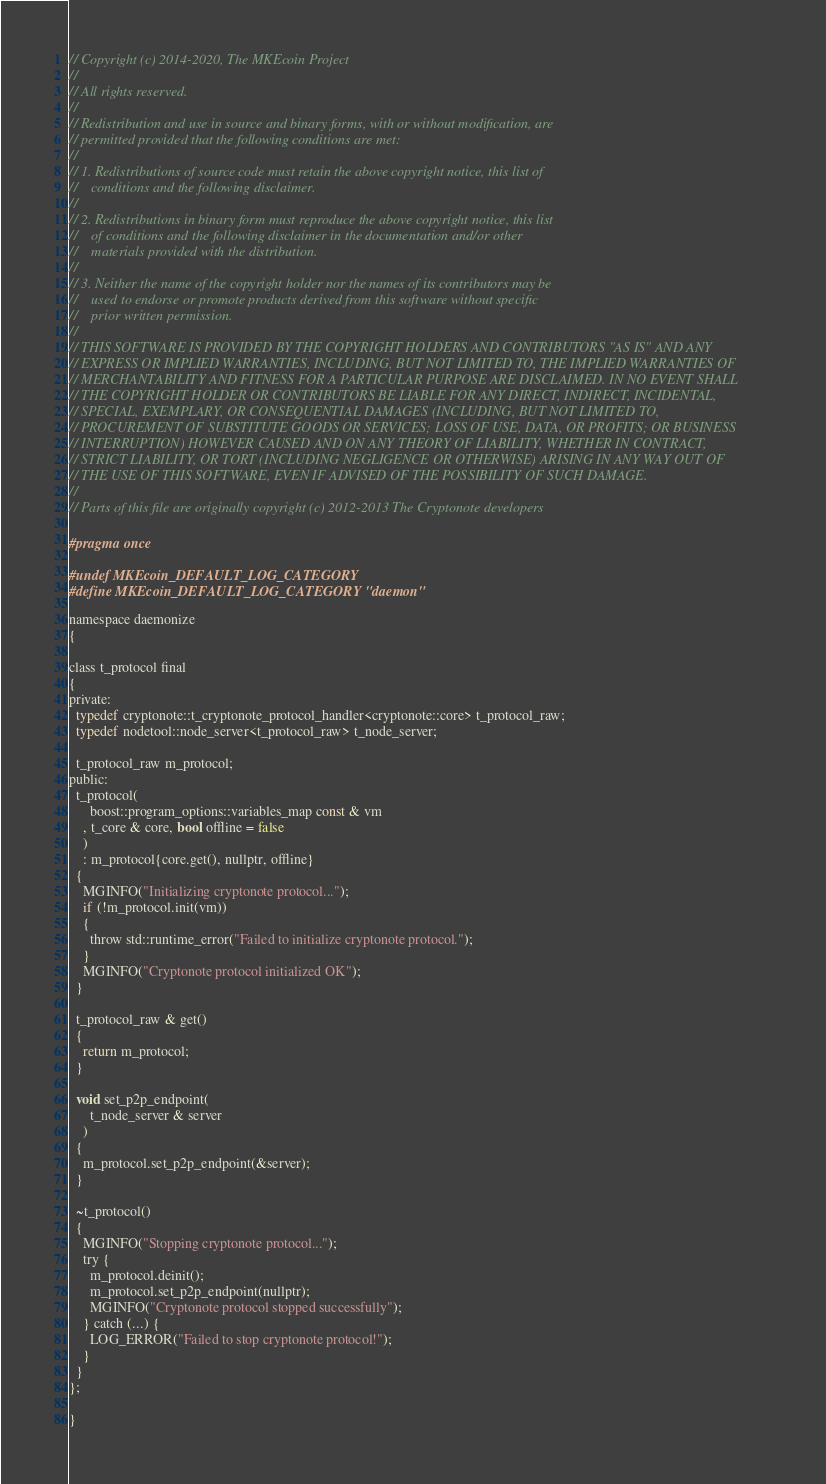<code> <loc_0><loc_0><loc_500><loc_500><_C_>// Copyright (c) 2014-2020, The MKEcoin Project
// 
// All rights reserved.
// 
// Redistribution and use in source and binary forms, with or without modification, are
// permitted provided that the following conditions are met:
// 
// 1. Redistributions of source code must retain the above copyright notice, this list of
//    conditions and the following disclaimer.
// 
// 2. Redistributions in binary form must reproduce the above copyright notice, this list
//    of conditions and the following disclaimer in the documentation and/or other
//    materials provided with the distribution.
// 
// 3. Neither the name of the copyright holder nor the names of its contributors may be
//    used to endorse or promote products derived from this software without specific
//    prior written permission.
// 
// THIS SOFTWARE IS PROVIDED BY THE COPYRIGHT HOLDERS AND CONTRIBUTORS "AS IS" AND ANY
// EXPRESS OR IMPLIED WARRANTIES, INCLUDING, BUT NOT LIMITED TO, THE IMPLIED WARRANTIES OF
// MERCHANTABILITY AND FITNESS FOR A PARTICULAR PURPOSE ARE DISCLAIMED. IN NO EVENT SHALL
// THE COPYRIGHT HOLDER OR CONTRIBUTORS BE LIABLE FOR ANY DIRECT, INDIRECT, INCIDENTAL,
// SPECIAL, EXEMPLARY, OR CONSEQUENTIAL DAMAGES (INCLUDING, BUT NOT LIMITED TO,
// PROCUREMENT OF SUBSTITUTE GOODS OR SERVICES; LOSS OF USE, DATA, OR PROFITS; OR BUSINESS
// INTERRUPTION) HOWEVER CAUSED AND ON ANY THEORY OF LIABILITY, WHETHER IN CONTRACT,
// STRICT LIABILITY, OR TORT (INCLUDING NEGLIGENCE OR OTHERWISE) ARISING IN ANY WAY OUT OF
// THE USE OF THIS SOFTWARE, EVEN IF ADVISED OF THE POSSIBILITY OF SUCH DAMAGE.
//
// Parts of this file are originally copyright (c) 2012-2013 The Cryptonote developers

#pragma once

#undef MKEcoin_DEFAULT_LOG_CATEGORY
#define MKEcoin_DEFAULT_LOG_CATEGORY "daemon"

namespace daemonize
{

class t_protocol final
{
private:
  typedef cryptonote::t_cryptonote_protocol_handler<cryptonote::core> t_protocol_raw;
  typedef nodetool::node_server<t_protocol_raw> t_node_server;

  t_protocol_raw m_protocol;
public:
  t_protocol(
      boost::program_options::variables_map const & vm
    , t_core & core, bool offline = false
    )
    : m_protocol{core.get(), nullptr, offline}
  {
    MGINFO("Initializing cryptonote protocol...");
    if (!m_protocol.init(vm))
    {
      throw std::runtime_error("Failed to initialize cryptonote protocol.");
    }
    MGINFO("Cryptonote protocol initialized OK");
  }

  t_protocol_raw & get()
  {
    return m_protocol;
  }

  void set_p2p_endpoint(
      t_node_server & server
    )
  {
    m_protocol.set_p2p_endpoint(&server);
  }

  ~t_protocol()
  {
    MGINFO("Stopping cryptonote protocol...");
    try {
      m_protocol.deinit();
      m_protocol.set_p2p_endpoint(nullptr);
      MGINFO("Cryptonote protocol stopped successfully");
    } catch (...) {
      LOG_ERROR("Failed to stop cryptonote protocol!");
    }
  }
};

}
</code> 